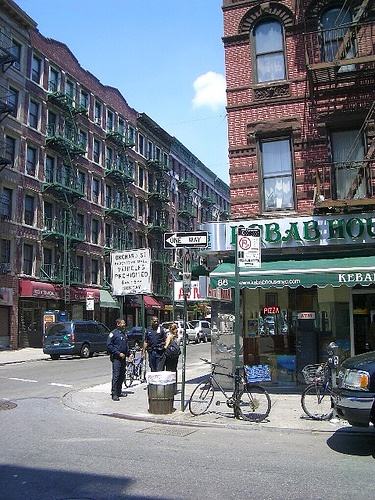Describe the objects in this image and their specific colors. I can see bicycle in black, lightgray, gray, and darkgray tones, car in black, darkgray, gray, and blue tones, car in black, navy, gray, and blue tones, bicycle in black, lightgray, gray, and darkgray tones, and people in black, gray, navy, and darkblue tones in this image. 